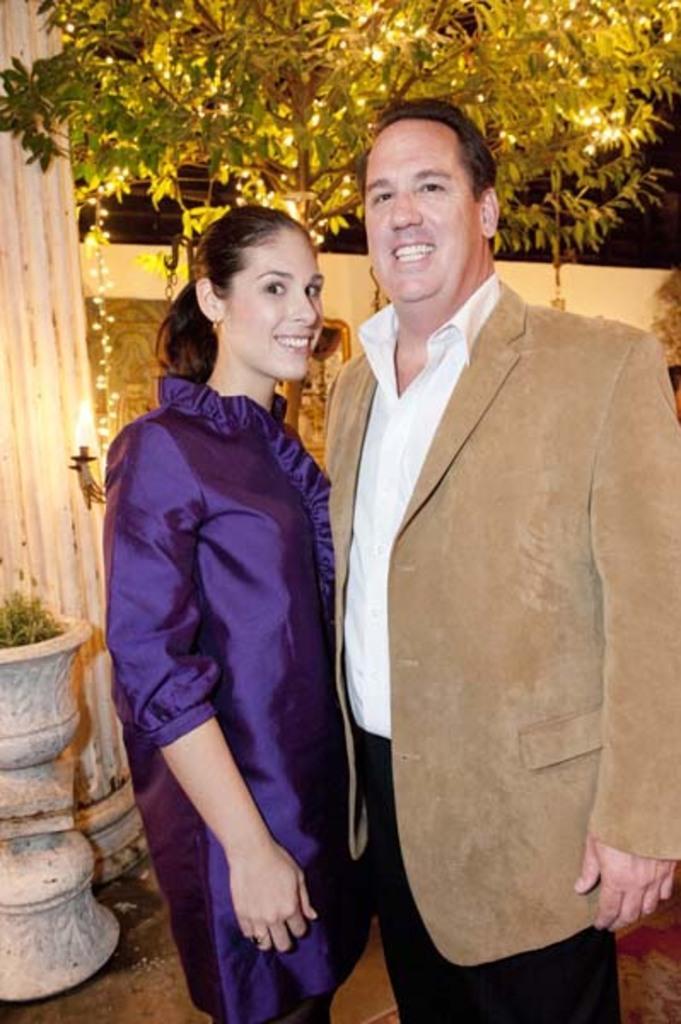Please provide a concise description of this image. In this image there is a woman standing beside the person. He is wearing a suit. Left side there is a pot having a plant. Behind there is a pillar. Beside few lights are hanged. Middle of the image there is a tree. Behind there is a wall. 